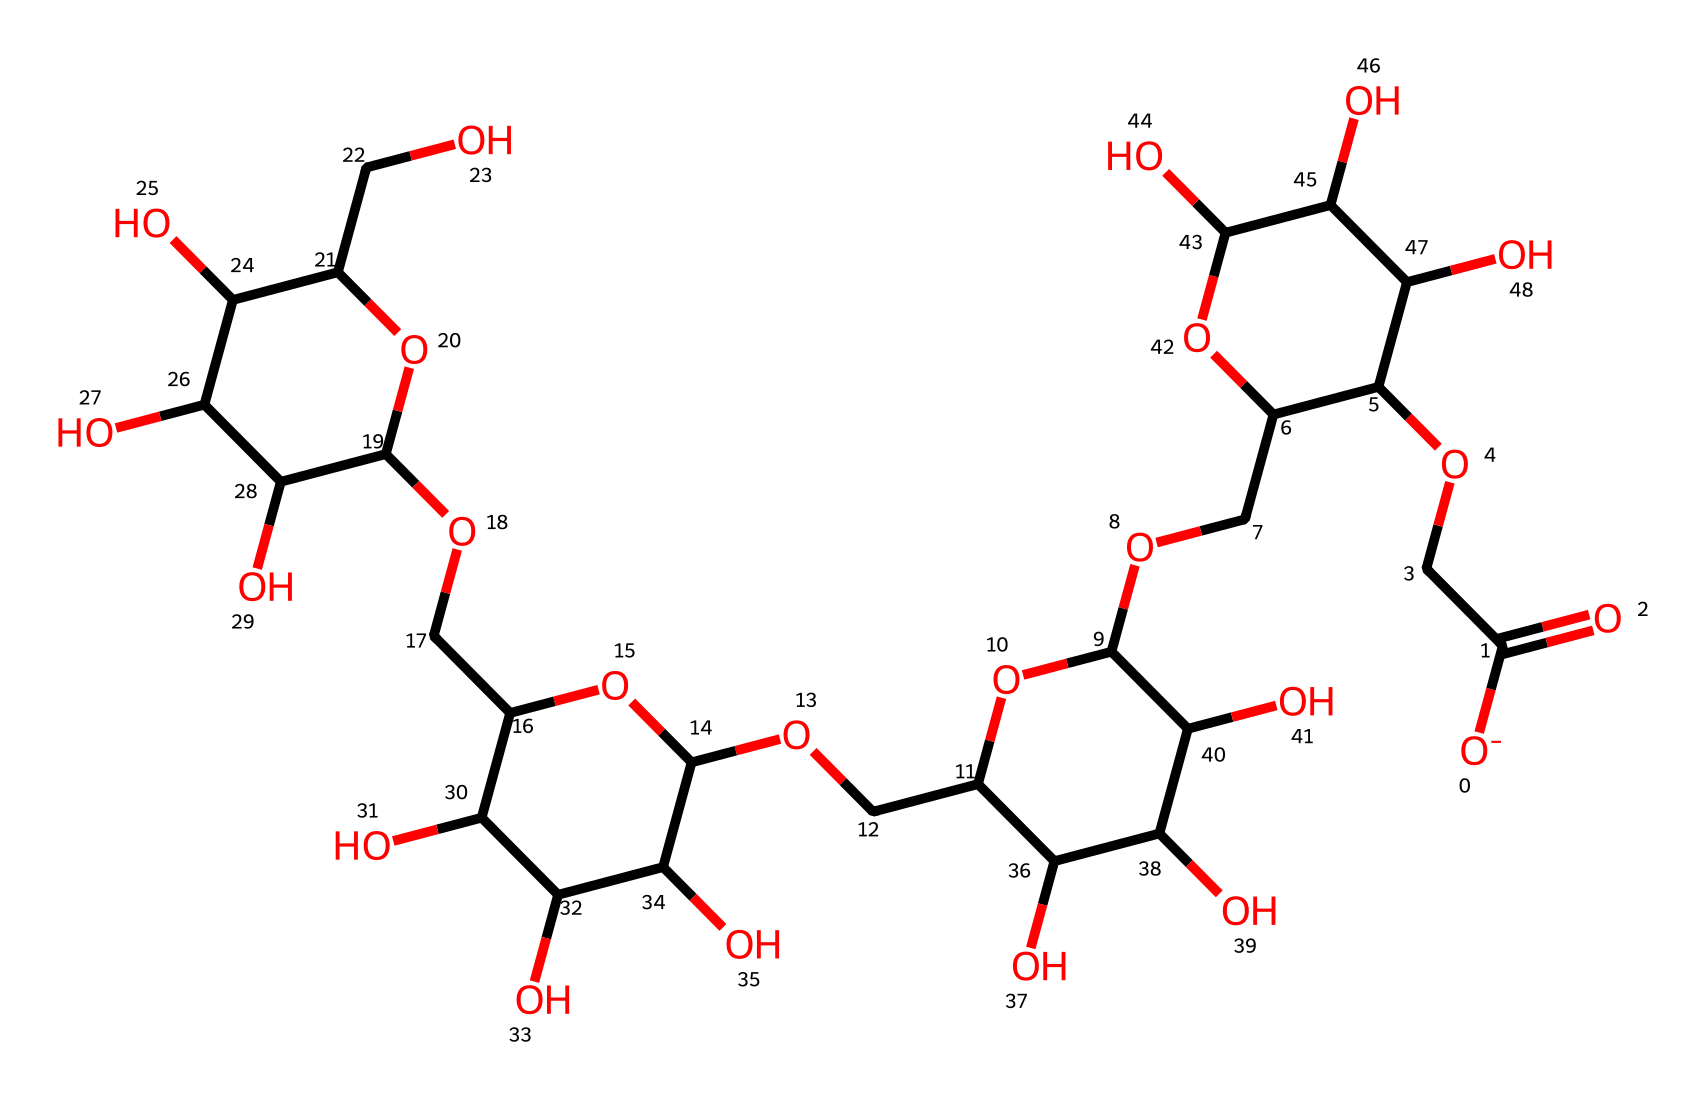What is the molecular formula of carboxymethyl cellulose? By analyzing the SMILES representation, we can decode and count all the carbon (C), hydrogen (H), and oxygen (O) atoms present in the structure. The molecular formula is derived from the total counts of these elements.
Answer: C7H14O7 How many carbon atoms are in carboxymethyl cellulose? In the SMILES string, we systematically identify and count each carbon atom represented. This leads us to conclude that there are seven carbon atoms.
Answer: 7 What functional groups can be identified in carboxymethyl cellulose? By examining the SMILES structure, we look for distinctive features such as hydroxyl (-OH) groups and the carboxylate (-COO-) group. These help classify its functional groups. The presence of multiple hydroxyl and one carboxylate functional group is notable.
Answer: hydroxyl, carboxylate What is the primary use of carboxymethyl cellulose in food products? Carboxymethyl cellulose acts primarily as a thickening agent, which can be inferred from its molecular structure indicating high viscosity and gelling properties.
Answer: thickening agent Is carboxymethyl cellulose soluble in water? Given the presence of many hydroxyl groups in the structure, which are polar and interact favorably with water, we can infer its solubility qualities. This indicates that carboxymethyl cellulose dissolves well in water.
Answer: yes How does the structure of carboxymethyl cellulose contribute to its thickening ability? The long chain and high number of hydroxyl groups increase the intermolecular interactions with water, enhancing its thickening capabilities. Additionally, the carboxylate group contributes to the ability to form gels, thus providing significant viscosity.
Answer: hydrogen bonding 